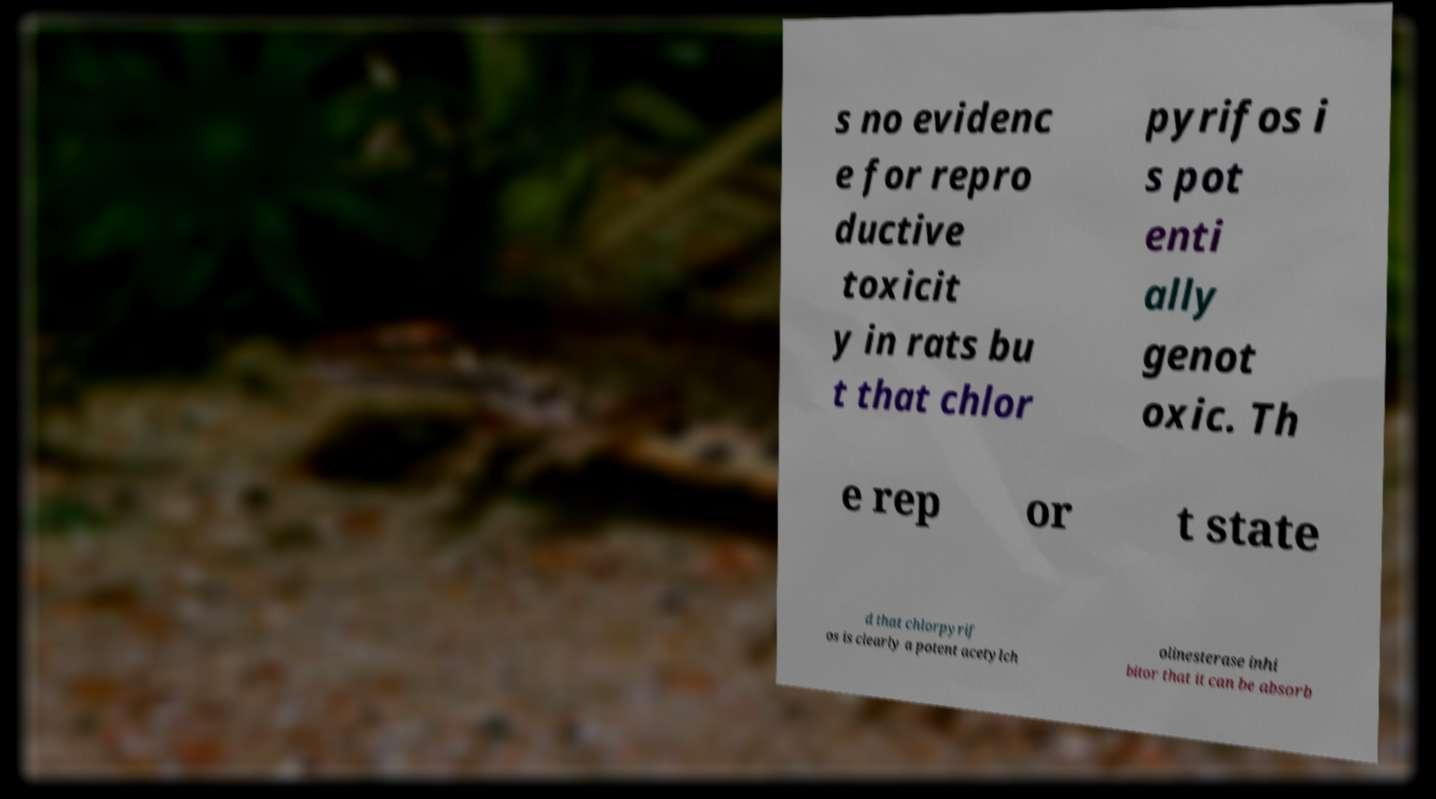I need the written content from this picture converted into text. Can you do that? s no evidenc e for repro ductive toxicit y in rats bu t that chlor pyrifos i s pot enti ally genot oxic. Th e rep or t state d that chlorpyrif os is clearly a potent acetylch olinesterase inhi bitor that it can be absorb 